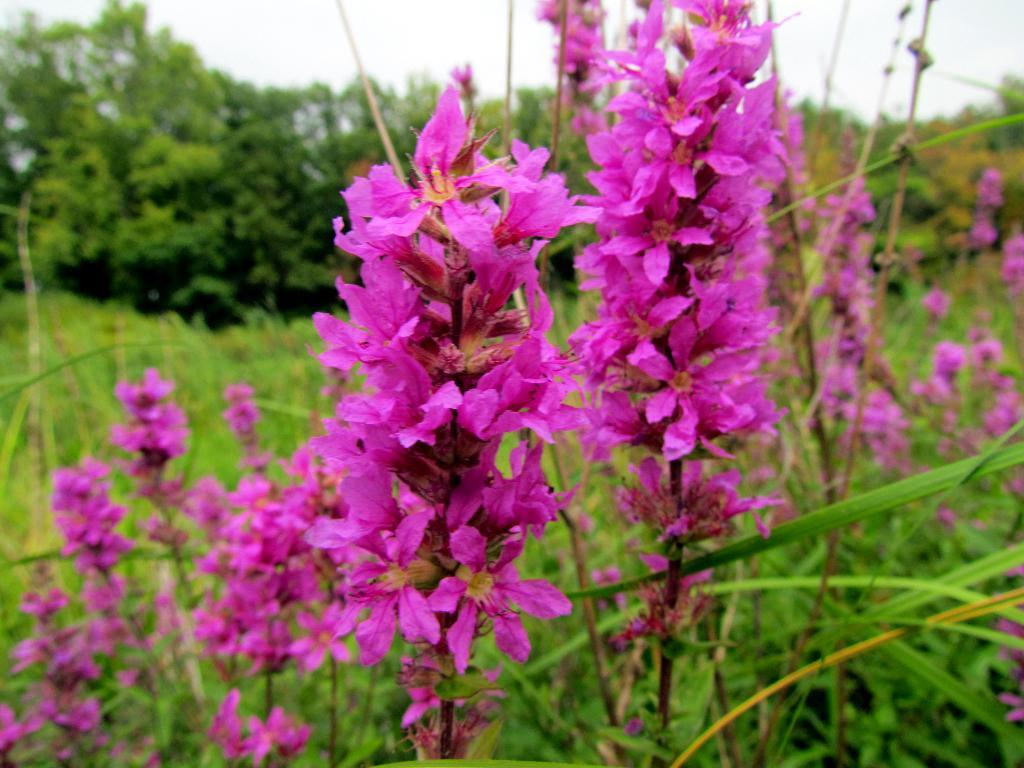What type of vegetation can be seen in the image? There are flowers on plants, grass, and trees visible in the image. How is the ground covered in the image? The ground is covered with grass and plants. What is visible in the sky in the image? The sky is cloudy in the image. What does the moon smell like in the image? There is no moon visible in the image, so it is not possible to determine what it might smell like. 